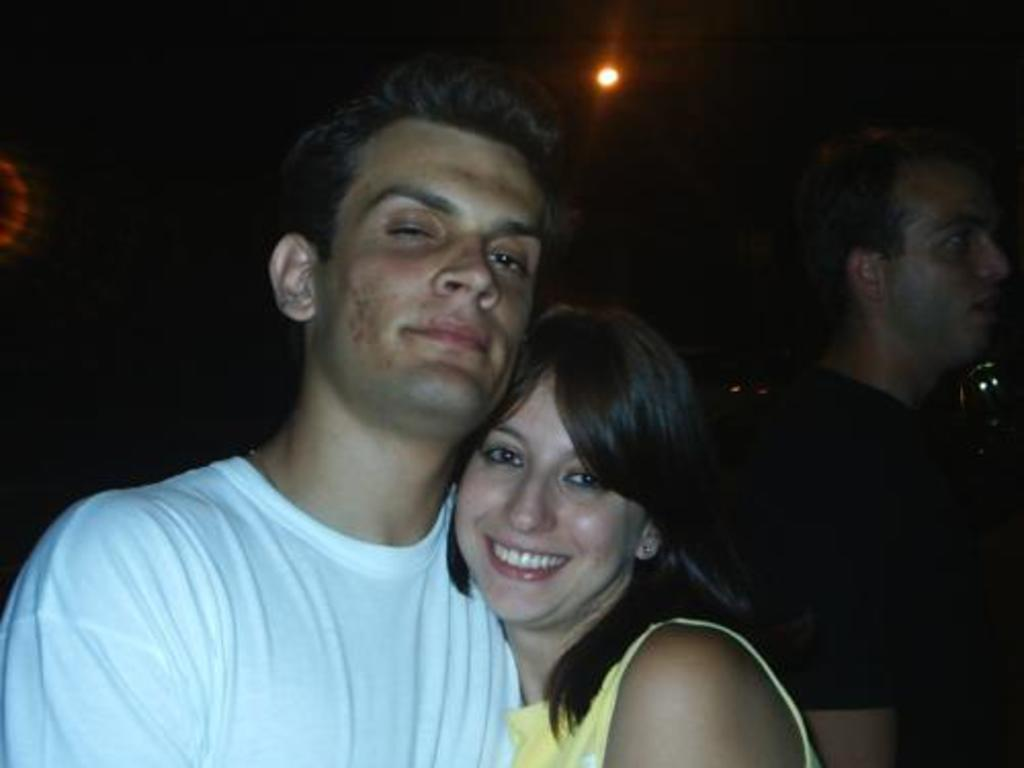How many people are present in the image? There are two people, a man and a woman, present in the image. What is the man wearing in the image? The man is wearing a white shirt in the image. What are the people in the image doing? The image only shows people standing, but their specific actions are not clear. What can be seen in the background of the image? There is a light in the background of the image. What type of drug is the crow holding in the image? There is no crow or drug present in the image. 